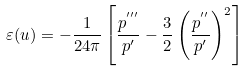Convert formula to latex. <formula><loc_0><loc_0><loc_500><loc_500>\varepsilon ( u ) = - \frac { 1 } { 2 4 \pi } \left [ \frac { p ^ { ^ { \prime \prime \prime } } } { p ^ { \prime } } - \frac { 3 } { 2 } \left ( \frac { p ^ { ^ { \prime \prime } } } { p ^ { \prime } } \right ) ^ { 2 } \right ]</formula> 